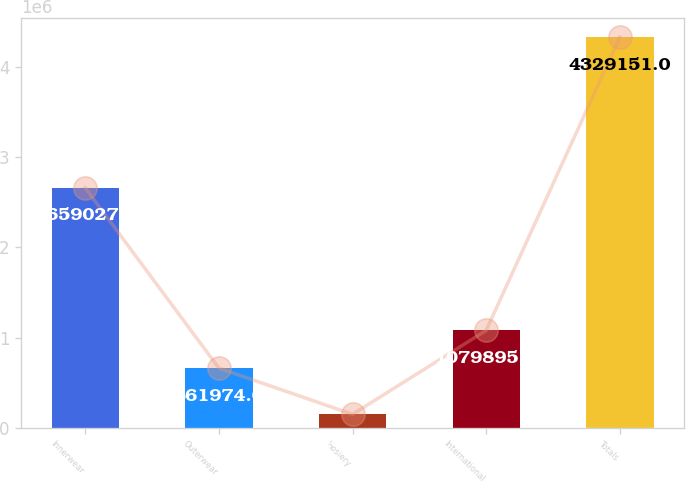Convert chart to OTSL. <chart><loc_0><loc_0><loc_500><loc_500><bar_chart><fcel>Innerwear<fcel>Outerwear<fcel>Hosiery<fcel>International<fcel>Totals<nl><fcel>2.65903e+06<fcel>661974<fcel>149934<fcel>1.0799e+06<fcel>4.32915e+06<nl></chart> 